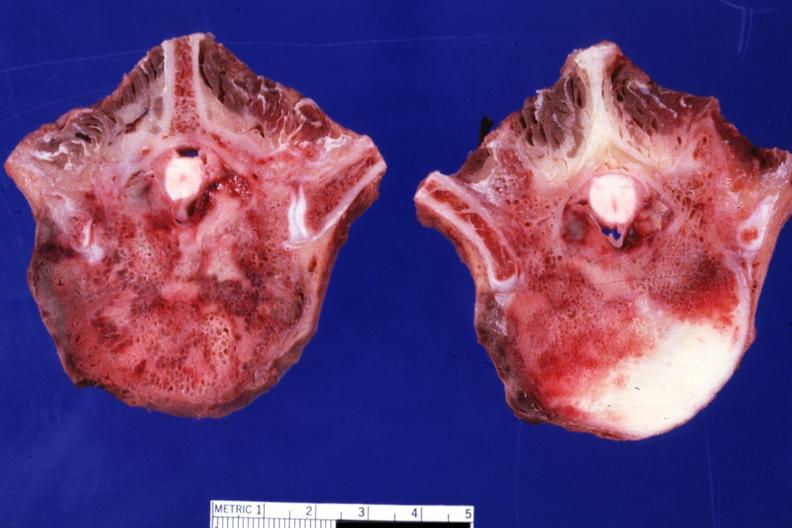does this image show excellent close-up of two vertebral bodies with obvious tumor teratocarcinoma primary in mediastinum?
Answer the question using a single word or phrase. Yes 